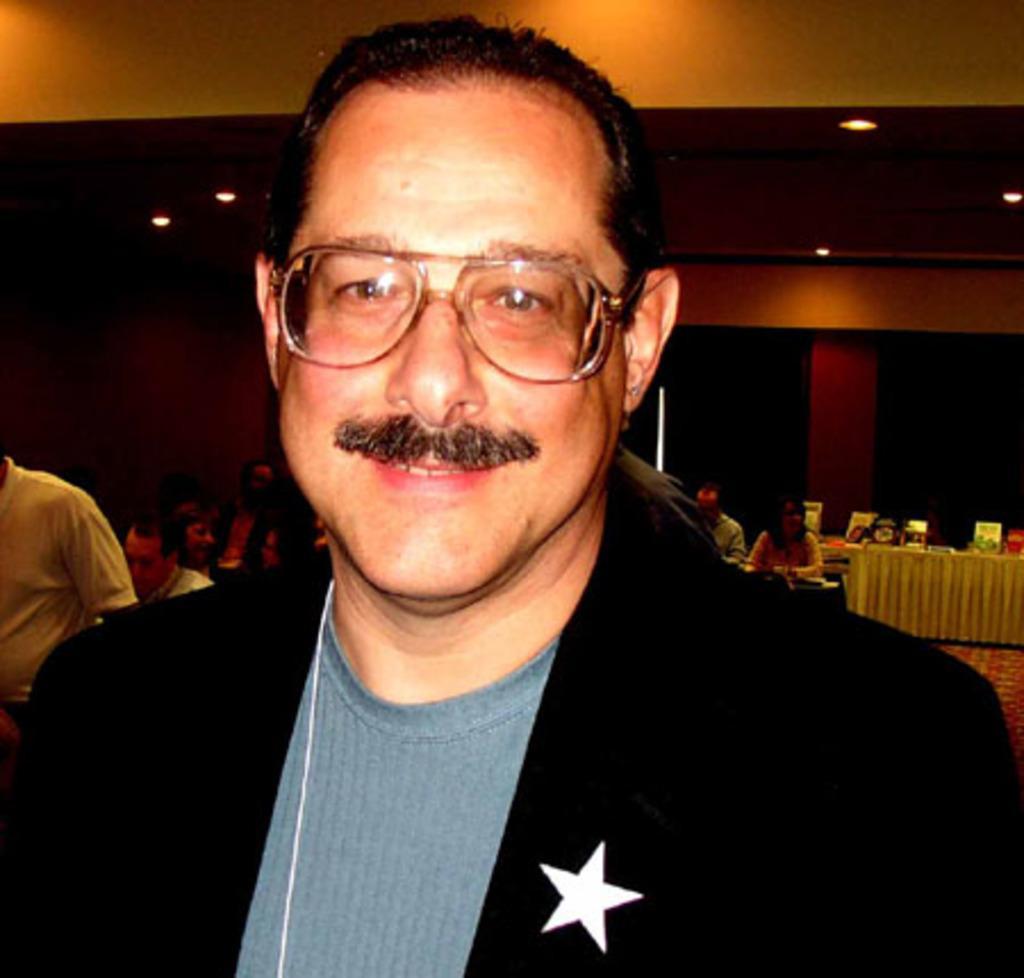Please provide a concise description of this image. In this image, we can see a man sitting and he is wearing a black color jacket, he is wearing specs, in the background there are some people sitting and there is a table, at the top there are some lights. 